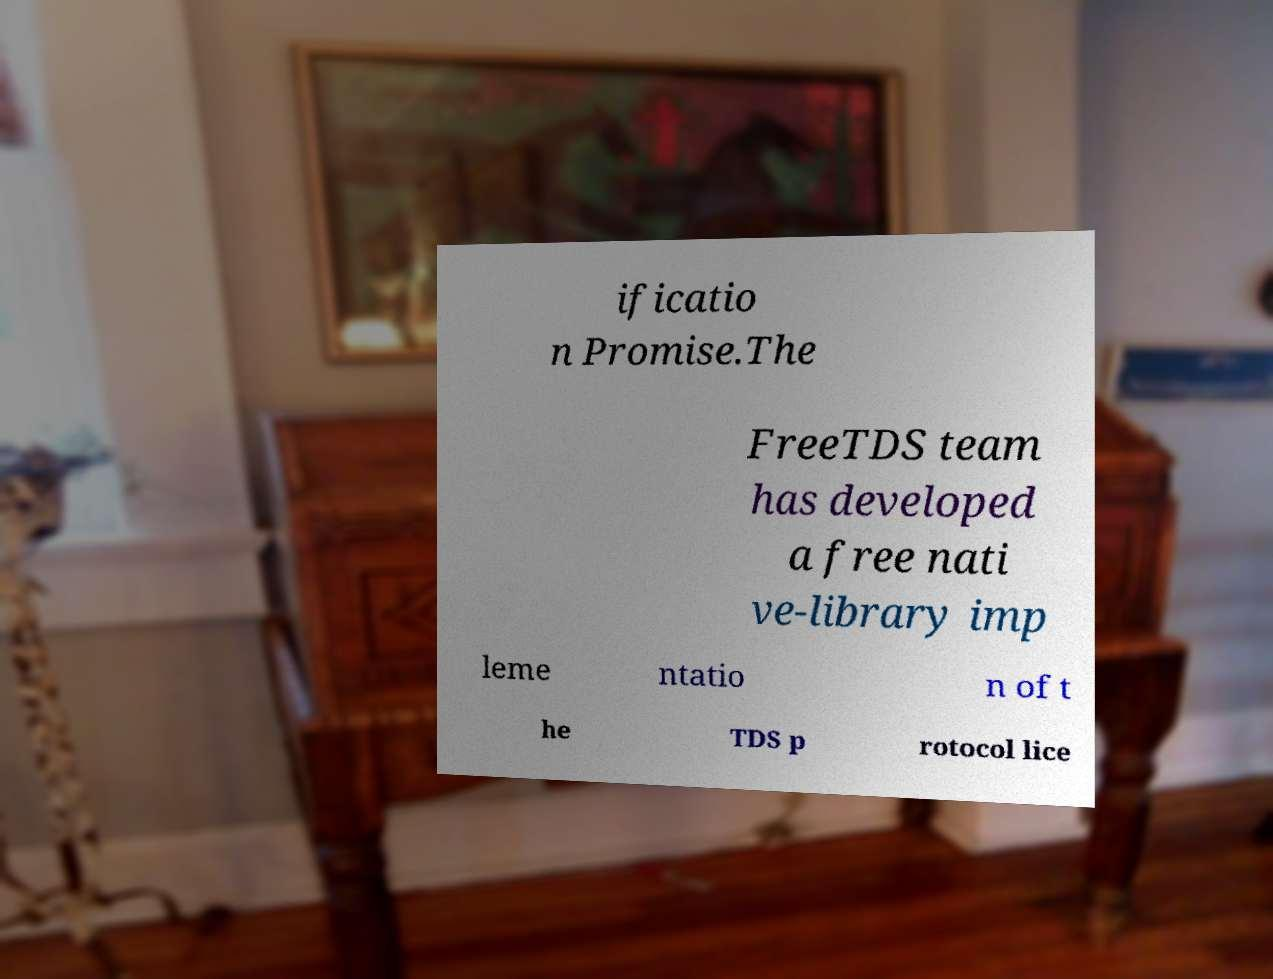Please identify and transcribe the text found in this image. ificatio n Promise.The FreeTDS team has developed a free nati ve-library imp leme ntatio n of t he TDS p rotocol lice 